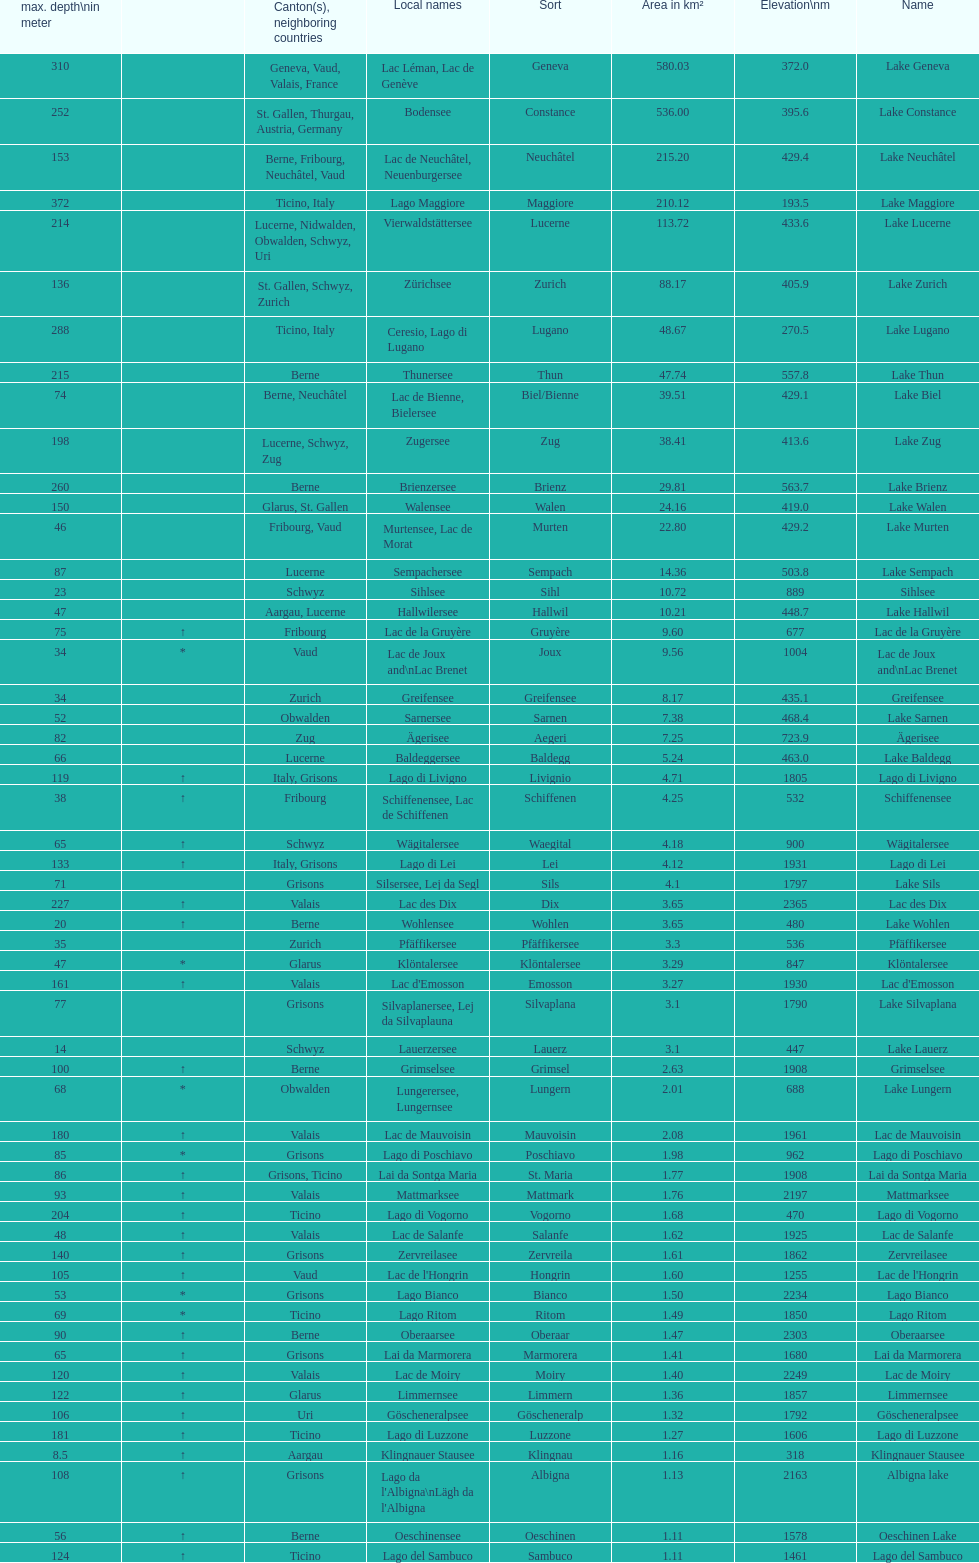Which is the only lake with a max depth of 372m? Lake Maggiore. 